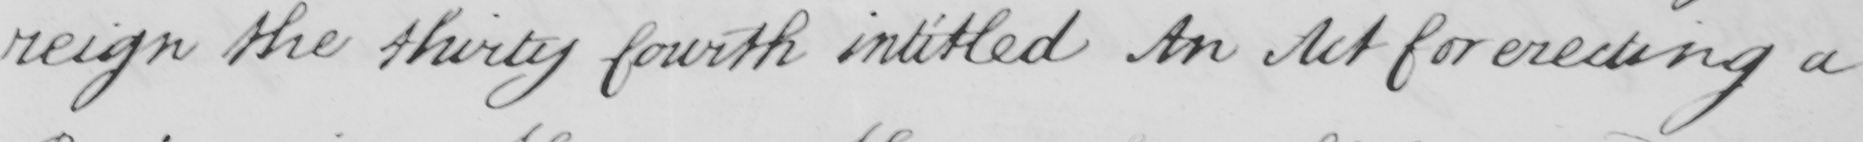Please provide the text content of this handwritten line. reign the thirty fourth intitled An Act for erecting a 